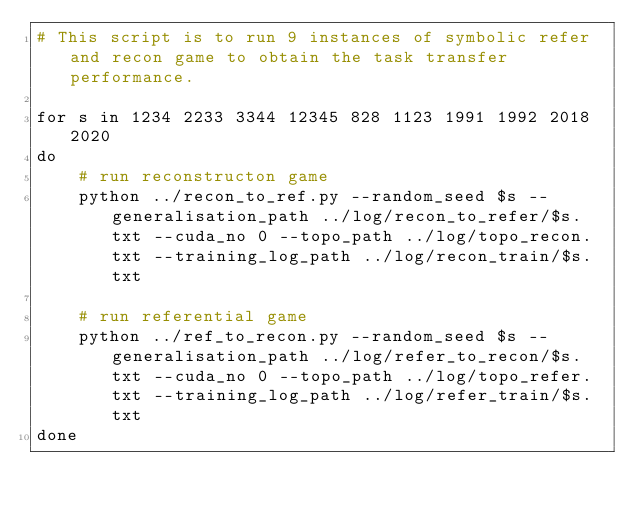<code> <loc_0><loc_0><loc_500><loc_500><_Bash_># This script is to run 9 instances of symbolic refer and recon game to obtain the task transfer performance.

for s in 1234 2233 3344 12345 828 1123 1991 1992 2018 2020
do
    # run reconstructon game
    python ../recon_to_ref.py --random_seed $s --generalisation_path ../log/recon_to_refer/$s.txt --cuda_no 0 --topo_path ../log/topo_recon.txt --training_log_path ../log/recon_train/$s.txt

    # run referential game
    python ../ref_to_recon.py --random_seed $s --generalisation_path ../log/refer_to_recon/$s.txt --cuda_no 0 --topo_path ../log/topo_refer.txt --training_log_path ../log/refer_train/$s.txt
done
</code> 